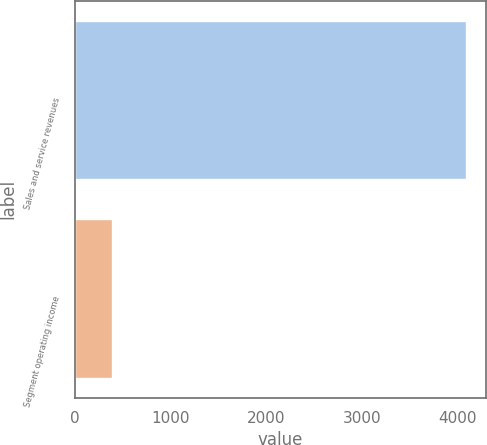Convert chart. <chart><loc_0><loc_0><loc_500><loc_500><bar_chart><fcel>Sales and service revenues<fcel>Segment operating income<nl><fcel>4089<fcel>386<nl></chart> 